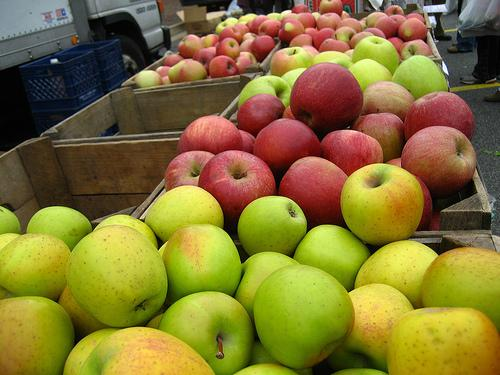Describe any footwear and clothing specific to a person in the image. A person is wearing grey gym shoes, black pants, and a white shirt. Can you identify any vehicles and their attributes in the image? There is a parked white truck with a metal side next to blue crates, and its wheels are black and silver. What can you say about the apple trays and crates in the image, based on the given information? There are wooden apple trays, a blue color plastic tray, and wooden crates with some being empty. Tell me about the cases of apples that are mentioned in the image. There are crates of green and red apples, two crates of yellow apples in the foreground, and a case of red apples between two cases of yellow apples. Identify the type and color of the crates in the image. There are blue stacked plastic crates and empty dark wooden crates in the image. What types of bags and boxes can be found in the image? There is a brown cardboard box and a plastic shopping bag. Outline the type and characteristic of the illuminated apples in the image. There are fresh-looking green apples and fresh-looking pink apples. What are the noticeable colors of fruits in the image? Green, red, and yellow colors are noticeable among the fruits in the image. Please provide a count of green and red apples in the image. There are piles of green apples and red apples, but an exact count cannot be determined. Describe any two different surroundings of green apples in the image. Green apples are present in a wooden tray and piled next to red apples. 